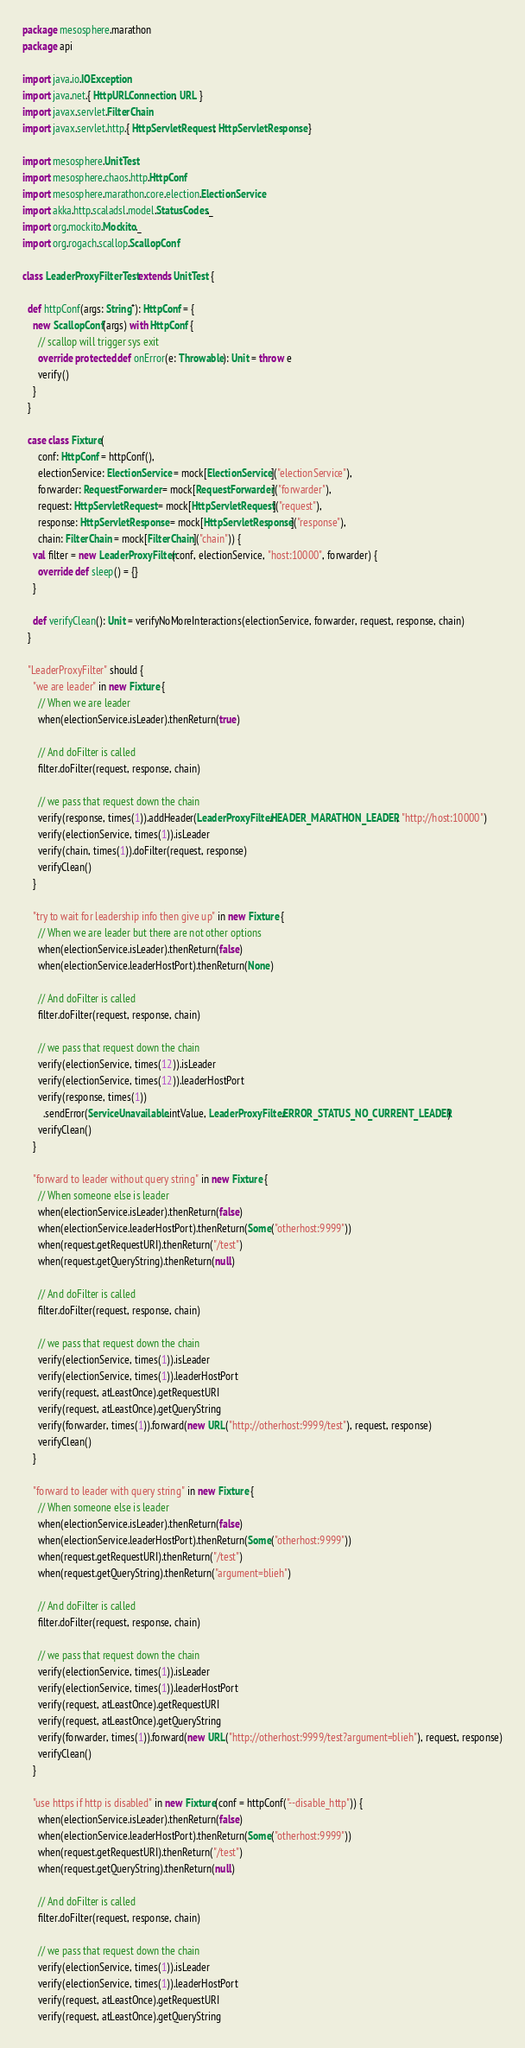Convert code to text. <code><loc_0><loc_0><loc_500><loc_500><_Scala_>package mesosphere.marathon
package api

import java.io.IOException
import java.net.{ HttpURLConnection, URL }
import javax.servlet.FilterChain
import javax.servlet.http.{ HttpServletRequest, HttpServletResponse }

import mesosphere.UnitTest
import mesosphere.chaos.http.HttpConf
import mesosphere.marathon.core.election.ElectionService
import akka.http.scaladsl.model.StatusCodes._
import org.mockito.Mockito._
import org.rogach.scallop.ScallopConf

class LeaderProxyFilterTest extends UnitTest {

  def httpConf(args: String*): HttpConf = {
    new ScallopConf(args) with HttpConf {
      // scallop will trigger sys exit
      override protected def onError(e: Throwable): Unit = throw e
      verify()
    }
  }

  case class Fixture(
      conf: HttpConf = httpConf(),
      electionService: ElectionService = mock[ElectionService]("electionService"),
      forwarder: RequestForwarder = mock[RequestForwarder]("forwarder"),
      request: HttpServletRequest = mock[HttpServletRequest]("request"),
      response: HttpServletResponse = mock[HttpServletResponse]("response"),
      chain: FilterChain = mock[FilterChain]("chain")) {
    val filter = new LeaderProxyFilter(conf, electionService, "host:10000", forwarder) {
      override def sleep() = {}
    }

    def verifyClean(): Unit = verifyNoMoreInteractions(electionService, forwarder, request, response, chain)
  }

  "LeaderProxyFilter" should {
    "we are leader" in new Fixture {
      // When we are leader
      when(electionService.isLeader).thenReturn(true)

      // And doFilter is called
      filter.doFilter(request, response, chain)

      // we pass that request down the chain
      verify(response, times(1)).addHeader(LeaderProxyFilter.HEADER_MARATHON_LEADER, "http://host:10000")
      verify(electionService, times(1)).isLeader
      verify(chain, times(1)).doFilter(request, response)
      verifyClean()
    }

    "try to wait for leadership info then give up" in new Fixture {
      // When we are leader but there are not other options
      when(electionService.isLeader).thenReturn(false)
      when(electionService.leaderHostPort).thenReturn(None)

      // And doFilter is called
      filter.doFilter(request, response, chain)

      // we pass that request down the chain
      verify(electionService, times(12)).isLeader
      verify(electionService, times(12)).leaderHostPort
      verify(response, times(1))
        .sendError(ServiceUnavailable.intValue, LeaderProxyFilter.ERROR_STATUS_NO_CURRENT_LEADER)
      verifyClean()
    }

    "forward to leader without query string" in new Fixture {
      // When someone else is leader
      when(electionService.isLeader).thenReturn(false)
      when(electionService.leaderHostPort).thenReturn(Some("otherhost:9999"))
      when(request.getRequestURI).thenReturn("/test")
      when(request.getQueryString).thenReturn(null)

      // And doFilter is called
      filter.doFilter(request, response, chain)

      // we pass that request down the chain
      verify(electionService, times(1)).isLeader
      verify(electionService, times(1)).leaderHostPort
      verify(request, atLeastOnce).getRequestURI
      verify(request, atLeastOnce).getQueryString
      verify(forwarder, times(1)).forward(new URL("http://otherhost:9999/test"), request, response)
      verifyClean()
    }

    "forward to leader with query string" in new Fixture {
      // When someone else is leader
      when(electionService.isLeader).thenReturn(false)
      when(electionService.leaderHostPort).thenReturn(Some("otherhost:9999"))
      when(request.getRequestURI).thenReturn("/test")
      when(request.getQueryString).thenReturn("argument=blieh")

      // And doFilter is called
      filter.doFilter(request, response, chain)

      // we pass that request down the chain
      verify(electionService, times(1)).isLeader
      verify(electionService, times(1)).leaderHostPort
      verify(request, atLeastOnce).getRequestURI
      verify(request, atLeastOnce).getQueryString
      verify(forwarder, times(1)).forward(new URL("http://otherhost:9999/test?argument=blieh"), request, response)
      verifyClean()
    }

    "use https if http is disabled" in new Fixture(conf = httpConf("--disable_http")) {
      when(electionService.isLeader).thenReturn(false)
      when(electionService.leaderHostPort).thenReturn(Some("otherhost:9999"))
      when(request.getRequestURI).thenReturn("/test")
      when(request.getQueryString).thenReturn(null)

      // And doFilter is called
      filter.doFilter(request, response, chain)

      // we pass that request down the chain
      verify(electionService, times(1)).isLeader
      verify(electionService, times(1)).leaderHostPort
      verify(request, atLeastOnce).getRequestURI
      verify(request, atLeastOnce).getQueryString</code> 